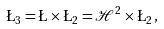<formula> <loc_0><loc_0><loc_500><loc_500>\L _ { 3 } = \L \times \L _ { 2 } = \mathcal { H } ^ { 2 } \times \L _ { 2 } \, ,</formula> 